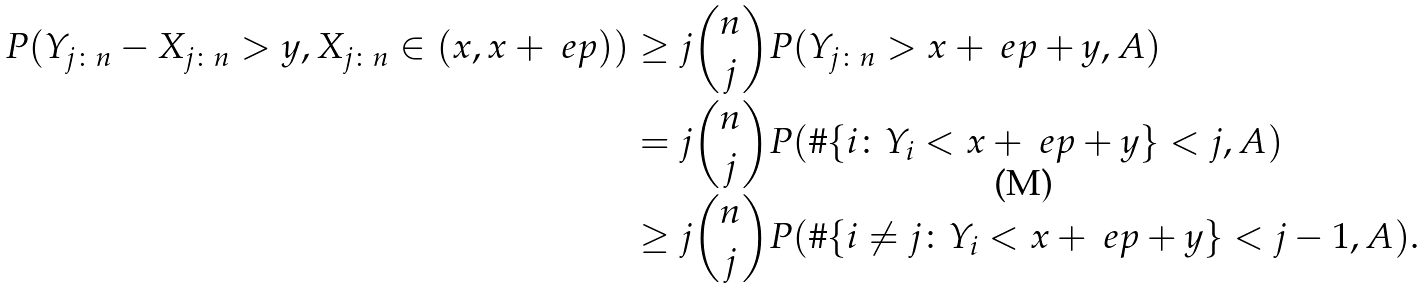Convert formula to latex. <formula><loc_0><loc_0><loc_500><loc_500>P ( Y _ { j \colon n } - X _ { j \colon n } > y , X _ { j \colon n } \in ( x , x + \ e p ) ) & \geq j \binom { n } { j } P ( Y _ { j \colon n } > x + \ e p + y , A ) \\ & = j \binom { n } { j } P ( \# \{ i \colon Y _ { i } < x + \ e p + y \} < j , A ) \\ & \geq j \binom { n } { j } P ( \# \{ i \ne j \colon Y _ { i } < x + \ e p + y \} < j - 1 , A ) .</formula> 